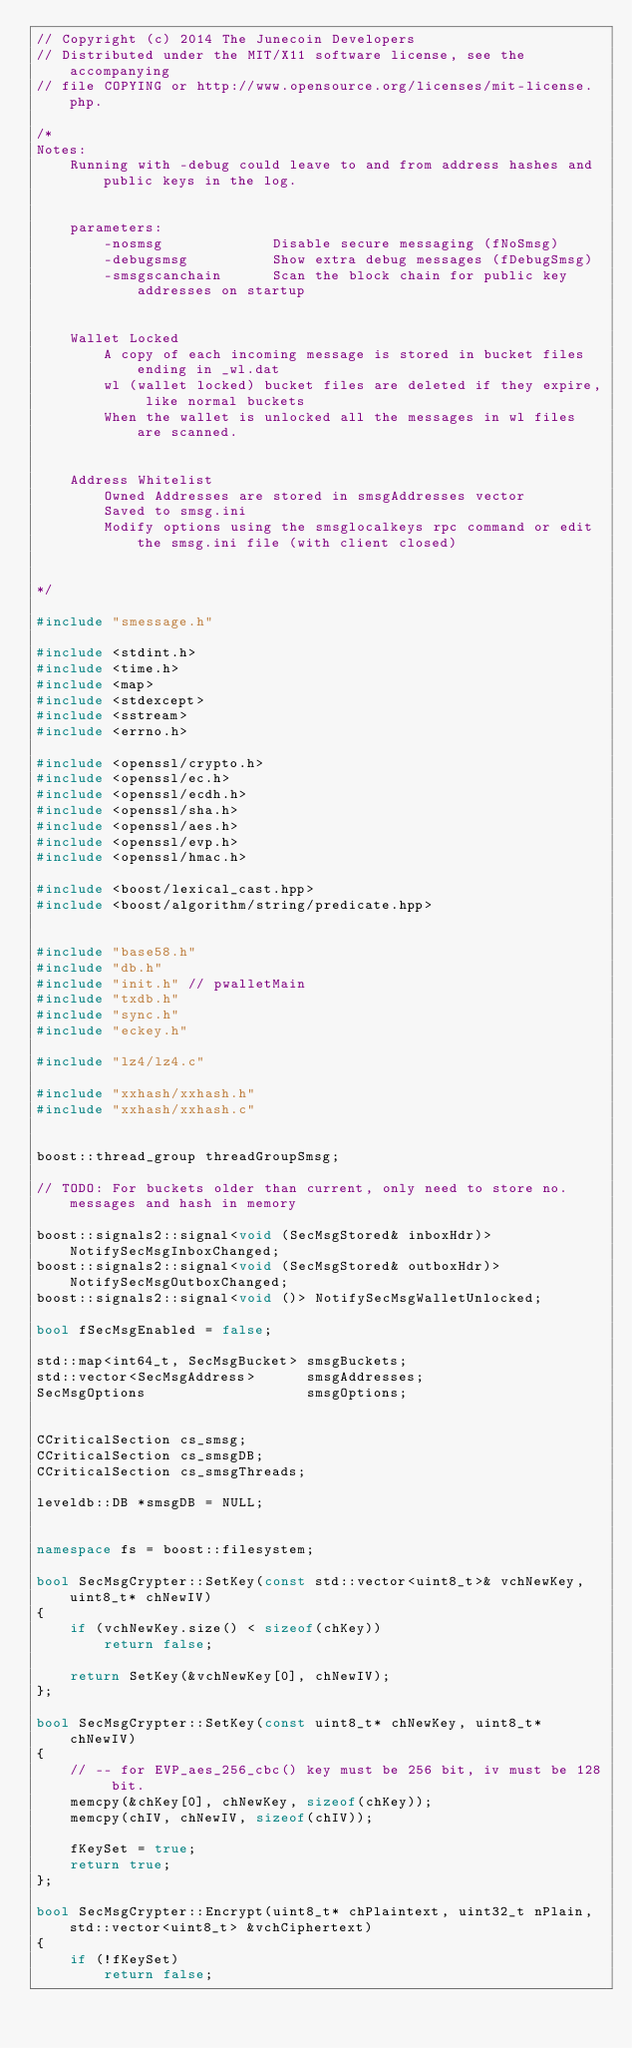Convert code to text. <code><loc_0><loc_0><loc_500><loc_500><_C++_>// Copyright (c) 2014 The Junecoin Developers
// Distributed under the MIT/X11 software license, see the accompanying
// file COPYING or http://www.opensource.org/licenses/mit-license.php.

/*
Notes:
    Running with -debug could leave to and from address hashes and public keys in the log.


    parameters:
        -nosmsg             Disable secure messaging (fNoSmsg)
        -debugsmsg          Show extra debug messages (fDebugSmsg)
        -smsgscanchain      Scan the block chain for public key addresses on startup


    Wallet Locked
        A copy of each incoming message is stored in bucket files ending in _wl.dat
        wl (wallet locked) bucket files are deleted if they expire, like normal buckets
        When the wallet is unlocked all the messages in wl files are scanned.


    Address Whitelist
        Owned Addresses are stored in smsgAddresses vector
        Saved to smsg.ini
        Modify options using the smsglocalkeys rpc command or edit the smsg.ini file (with client closed)


*/

#include "smessage.h"

#include <stdint.h>
#include <time.h>
#include <map>
#include <stdexcept>
#include <sstream>
#include <errno.h>

#include <openssl/crypto.h>
#include <openssl/ec.h>
#include <openssl/ecdh.h>
#include <openssl/sha.h>
#include <openssl/aes.h>
#include <openssl/evp.h>
#include <openssl/hmac.h>

#include <boost/lexical_cast.hpp>
#include <boost/algorithm/string/predicate.hpp>


#include "base58.h"
#include "db.h"
#include "init.h" // pwalletMain
#include "txdb.h"
#include "sync.h"
#include "eckey.h"

#include "lz4/lz4.c"

#include "xxhash/xxhash.h"
#include "xxhash/xxhash.c"


boost::thread_group threadGroupSmsg;

// TODO: For buckets older than current, only need to store no. messages and hash in memory

boost::signals2::signal<void (SecMsgStored& inboxHdr)>  NotifySecMsgInboxChanged;
boost::signals2::signal<void (SecMsgStored& outboxHdr)> NotifySecMsgOutboxChanged;
boost::signals2::signal<void ()> NotifySecMsgWalletUnlocked;

bool fSecMsgEnabled = false;

std::map<int64_t, SecMsgBucket> smsgBuckets;
std::vector<SecMsgAddress>      smsgAddresses;
SecMsgOptions                   smsgOptions;


CCriticalSection cs_smsg;
CCriticalSection cs_smsgDB;
CCriticalSection cs_smsgThreads;

leveldb::DB *smsgDB = NULL;


namespace fs = boost::filesystem;

bool SecMsgCrypter::SetKey(const std::vector<uint8_t>& vchNewKey, uint8_t* chNewIV)
{
    if (vchNewKey.size() < sizeof(chKey))
        return false;

    return SetKey(&vchNewKey[0], chNewIV);
};

bool SecMsgCrypter::SetKey(const uint8_t* chNewKey, uint8_t* chNewIV)
{
    // -- for EVP_aes_256_cbc() key must be 256 bit, iv must be 128 bit.
    memcpy(&chKey[0], chNewKey, sizeof(chKey));
    memcpy(chIV, chNewIV, sizeof(chIV));

    fKeySet = true;
    return true;
};

bool SecMsgCrypter::Encrypt(uint8_t* chPlaintext, uint32_t nPlain, std::vector<uint8_t> &vchCiphertext)
{
    if (!fKeySet)
        return false;
</code> 